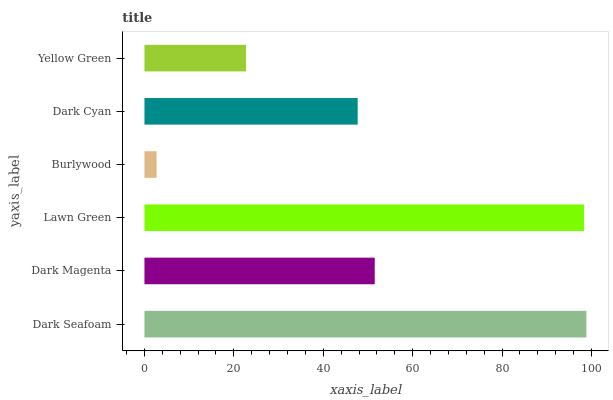Is Burlywood the minimum?
Answer yes or no. Yes. Is Dark Seafoam the maximum?
Answer yes or no. Yes. Is Dark Magenta the minimum?
Answer yes or no. No. Is Dark Magenta the maximum?
Answer yes or no. No. Is Dark Seafoam greater than Dark Magenta?
Answer yes or no. Yes. Is Dark Magenta less than Dark Seafoam?
Answer yes or no. Yes. Is Dark Magenta greater than Dark Seafoam?
Answer yes or no. No. Is Dark Seafoam less than Dark Magenta?
Answer yes or no. No. Is Dark Magenta the high median?
Answer yes or no. Yes. Is Dark Cyan the low median?
Answer yes or no. Yes. Is Dark Seafoam the high median?
Answer yes or no. No. Is Yellow Green the low median?
Answer yes or no. No. 